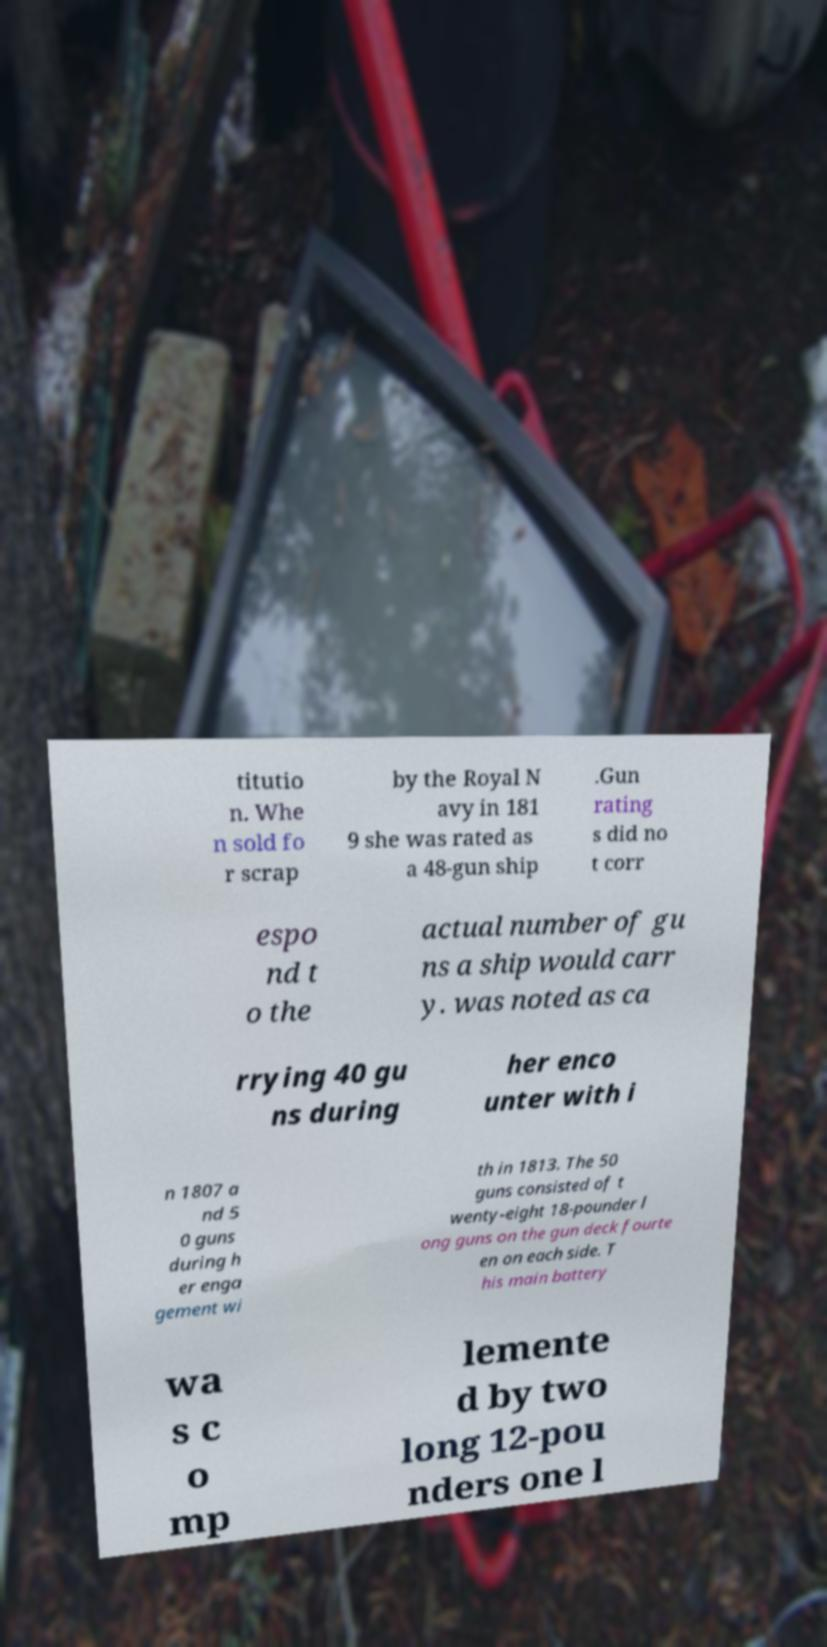Please identify and transcribe the text found in this image. titutio n. Whe n sold fo r scrap by the Royal N avy in 181 9 she was rated as a 48-gun ship .Gun rating s did no t corr espo nd t o the actual number of gu ns a ship would carr y. was noted as ca rrying 40 gu ns during her enco unter with i n 1807 a nd 5 0 guns during h er enga gement wi th in 1813. The 50 guns consisted of t wenty-eight 18-pounder l ong guns on the gun deck fourte en on each side. T his main battery wa s c o mp lemente d by two long 12-pou nders one l 